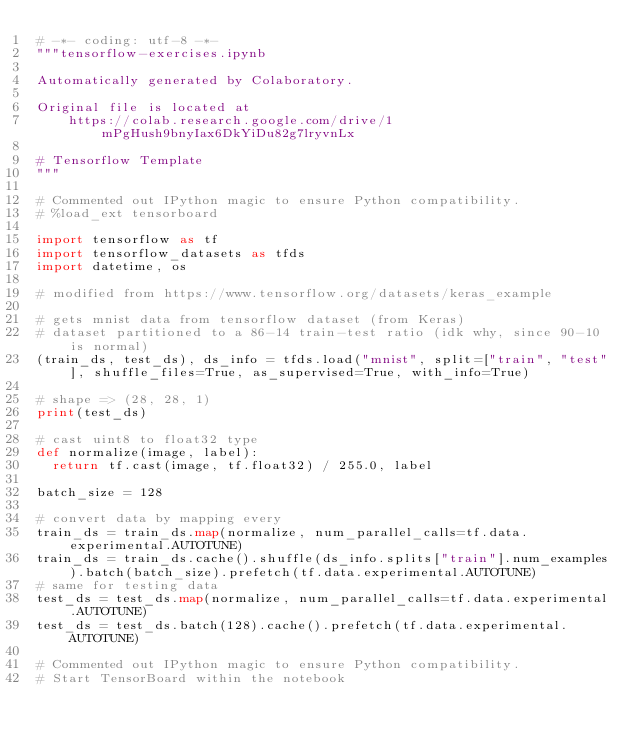<code> <loc_0><loc_0><loc_500><loc_500><_Python_># -*- coding: utf-8 -*-
"""tensorflow-exercises.ipynb

Automatically generated by Colaboratory.

Original file is located at
    https://colab.research.google.com/drive/1mPgHush9bnyIax6DkYiDu82g7lryvnLx

# Tensorflow Template
"""

# Commented out IPython magic to ensure Python compatibility.
# %load_ext tensorboard

import tensorflow as tf
import tensorflow_datasets as tfds
import datetime, os

# modified from https://www.tensorflow.org/datasets/keras_example

# gets mnist data from tensorflow dataset (from Keras)
# dataset partitioned to a 86-14 train-test ratio (idk why, since 90-10 is normal)
(train_ds, test_ds), ds_info = tfds.load("mnist", split=["train", "test"], shuffle_files=True, as_supervised=True, with_info=True)

# shape => (28, 28, 1)
print(test_ds)

# cast uint8 to float32 type
def normalize(image, label):
  return tf.cast(image, tf.float32) / 255.0, label

batch_size = 128

# convert data by mapping every 
train_ds = train_ds.map(normalize, num_parallel_calls=tf.data.experimental.AUTOTUNE)
train_ds = train_ds.cache().shuffle(ds_info.splits["train"].num_examples).batch(batch_size).prefetch(tf.data.experimental.AUTOTUNE)
# same for testing data
test_ds = test_ds.map(normalize, num_parallel_calls=tf.data.experimental.AUTOTUNE)
test_ds = test_ds.batch(128).cache().prefetch(tf.data.experimental.AUTOTUNE)

# Commented out IPython magic to ensure Python compatibility.
# Start TensorBoard within the notebook</code> 